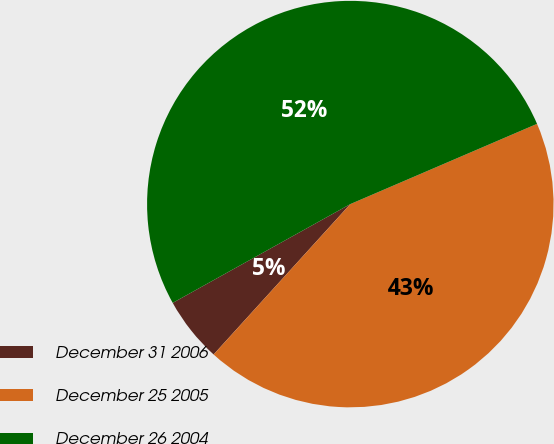Convert chart. <chart><loc_0><loc_0><loc_500><loc_500><pie_chart><fcel>December 31 2006<fcel>December 25 2005<fcel>December 26 2004<nl><fcel>5.18%<fcel>43.2%<fcel>51.62%<nl></chart> 